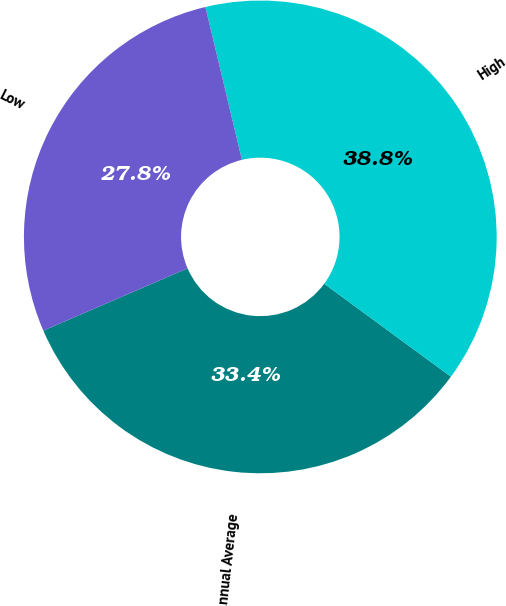Convert chart to OTSL. <chart><loc_0><loc_0><loc_500><loc_500><pie_chart><fcel>Annual Average<fcel>High<fcel>Low<nl><fcel>33.44%<fcel>38.8%<fcel>27.76%<nl></chart> 